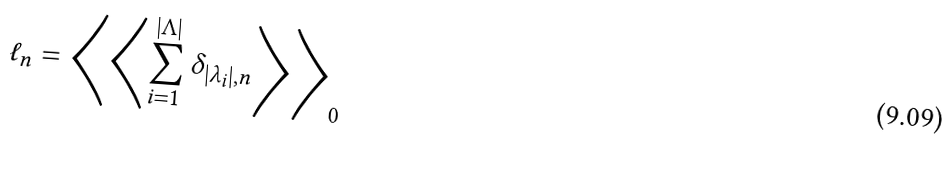<formula> <loc_0><loc_0><loc_500><loc_500>\ell _ { n } = \left \langle \left \langle \sum _ { i = 1 } ^ { | \Lambda | } \delta _ { | \lambda _ { i } | , n } \right \rangle \right \rangle _ { 0 }</formula> 